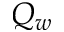Convert formula to latex. <formula><loc_0><loc_0><loc_500><loc_500>Q _ { w }</formula> 